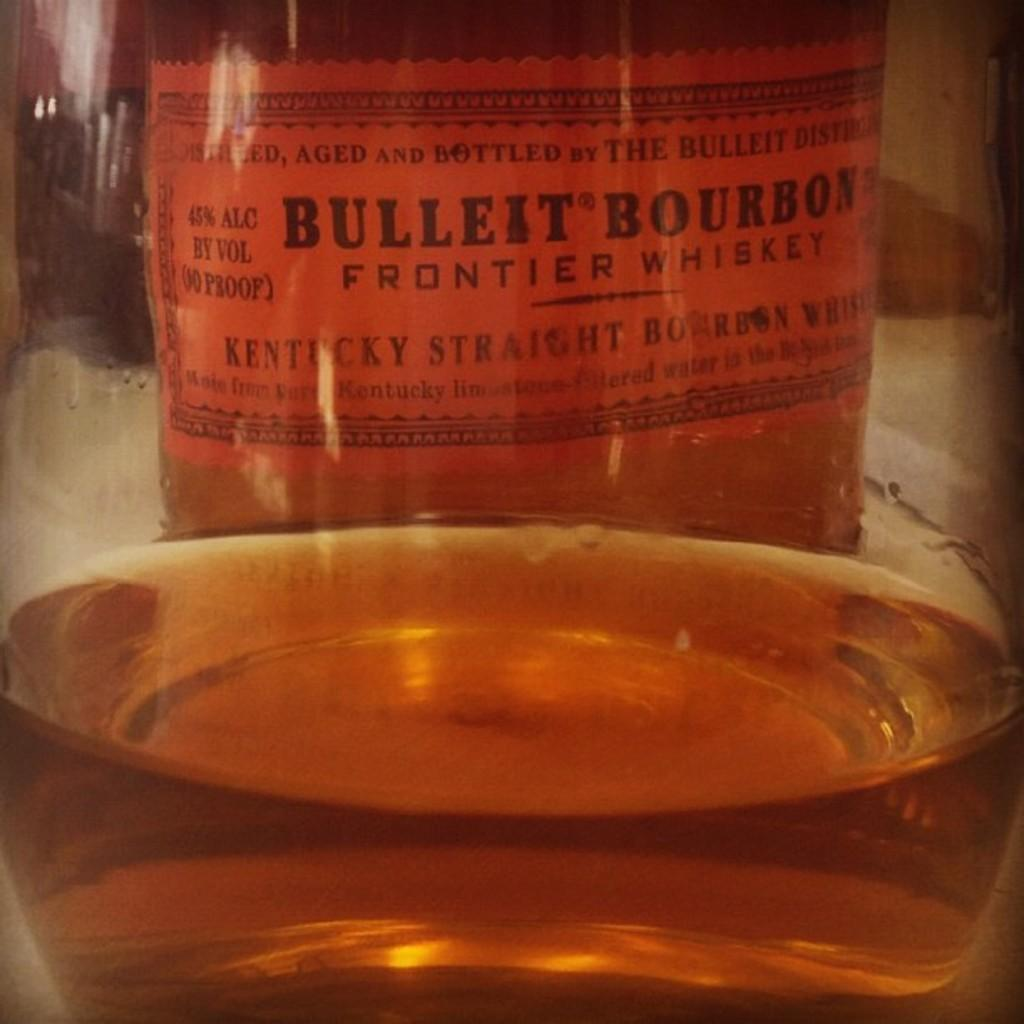<image>
Give a short and clear explanation of the subsequent image. A bottle with a label reading "Bullet Bourbon Frontier Whiskey" behind a glass that appears to hold the bottle's contents. 